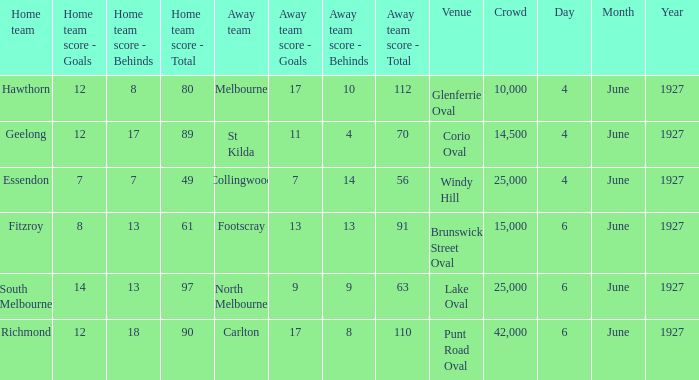Which venue's home team is geelong? Corio Oval. 